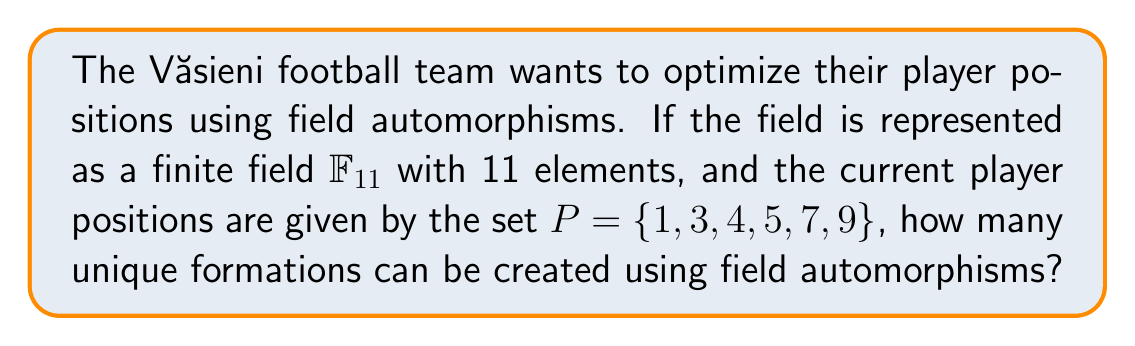Solve this math problem. Let's approach this step-by-step:

1) In a finite field $\mathbb{F}_p$ where $p$ is prime, the automorphisms are given by the Frobenius automorphisms:

   $\sigma_k(x) = x^{p^k}$ for $k = 0, 1, ..., n-1$, where $n$ is the smallest positive integer such that $p^n \equiv 1 \pmod{p}$.

2) In our case, $p = 11$. We need to find the smallest positive $n$ such that $11^n \equiv 1 \pmod{11}$.

3) By calculation:
   $11^1 \equiv 0 \pmod{11}$
   $11^2 \equiv 0 \pmod{11}$
   ...
   $11^{10} \equiv 1 \pmod{11}$

4) Therefore, $n = 10$, and we have 10 distinct automorphisms:

   $\sigma_k(x) = x^{11^k}$ for $k = 0, 1, ..., 9$

5) Now, we need to apply each of these automorphisms to our set $P = \{1, 3, 4, 5, 7, 9\}$:

   $\sigma_0(P) = \{1, 3, 4, 5, 7, 9\}$
   $\sigma_1(P) = \{1, 3, 4, 5, 7, 9\}$
   $\sigma_2(P) = \{1, 9, 3, 4, 5, 7\}$
   $\sigma_3(P) = \{1, 5, 9, 3, 4, 7\}$
   $\sigma_4(P) = \{1, 4, 5, 9, 3, 7\}$
   $\sigma_5(P) = \{1, 3, 4, 5, 9, 7\}$
   $\sigma_6(P) = \{1, 9, 3, 4, 5, 7\}$
   $\sigma_7(P) = \{1, 5, 9, 3, 4, 7\}$
   $\sigma_8(P) = \{1, 4, 5, 9, 3, 7\}$
   $\sigma_9(P) = \{1, 3, 4, 5, 9, 7\}$

6) Counting the unique sets, we find that there are 5 distinct formations.
Answer: 5 